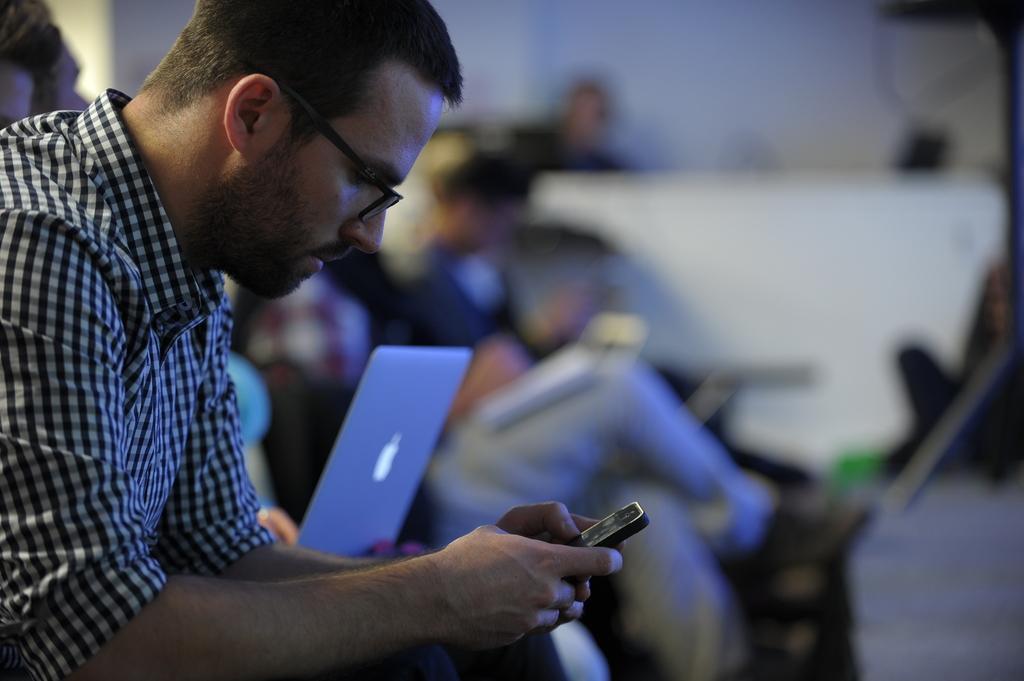Can you describe this image briefly? Few persons sitting. This person holding mobile. This is laptop. 